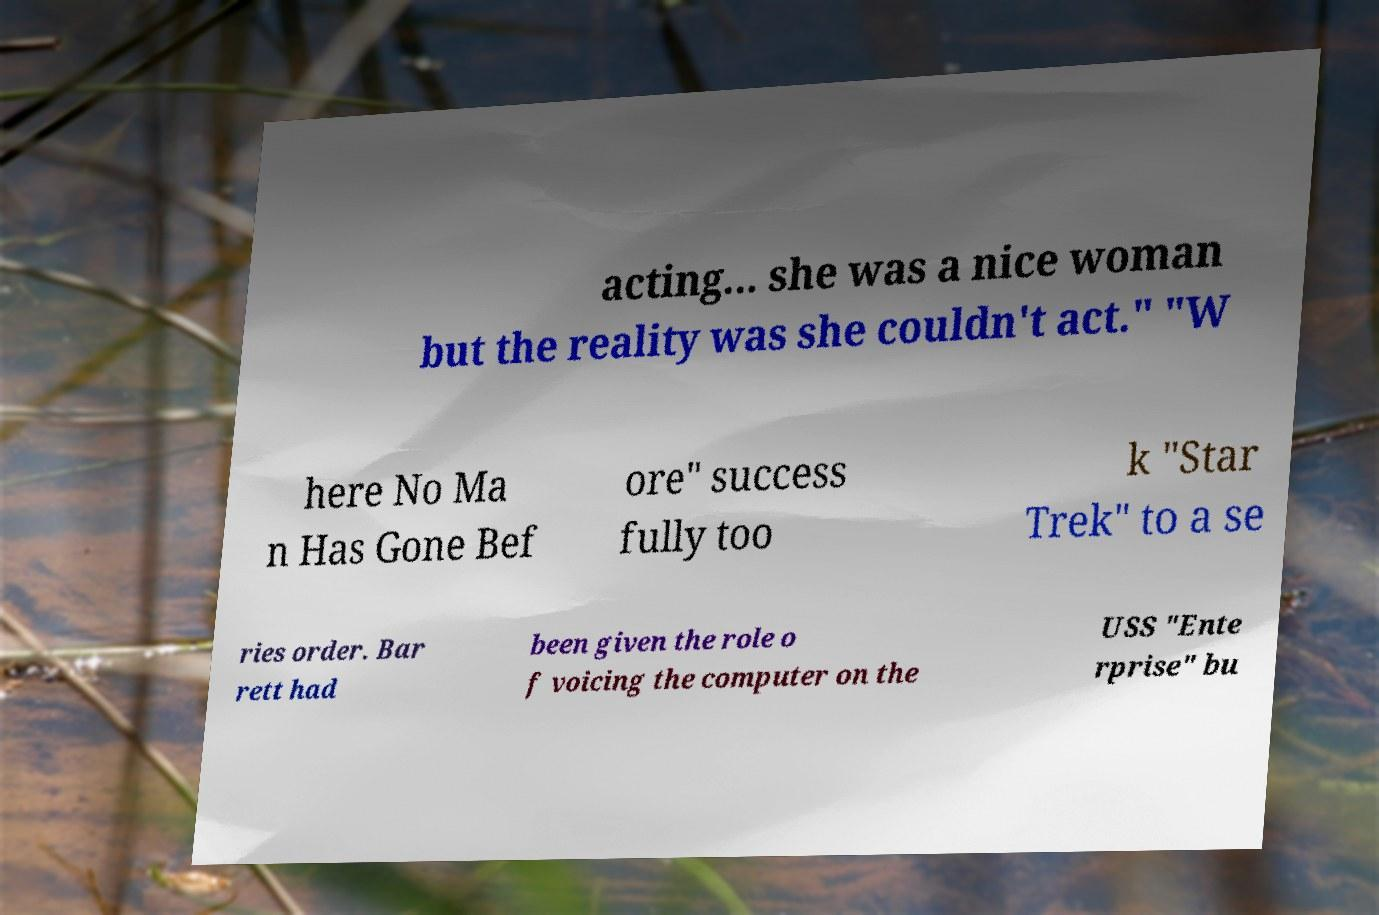I need the written content from this picture converted into text. Can you do that? acting... she was a nice woman but the reality was she couldn't act." "W here No Ma n Has Gone Bef ore" success fully too k "Star Trek" to a se ries order. Bar rett had been given the role o f voicing the computer on the USS "Ente rprise" bu 